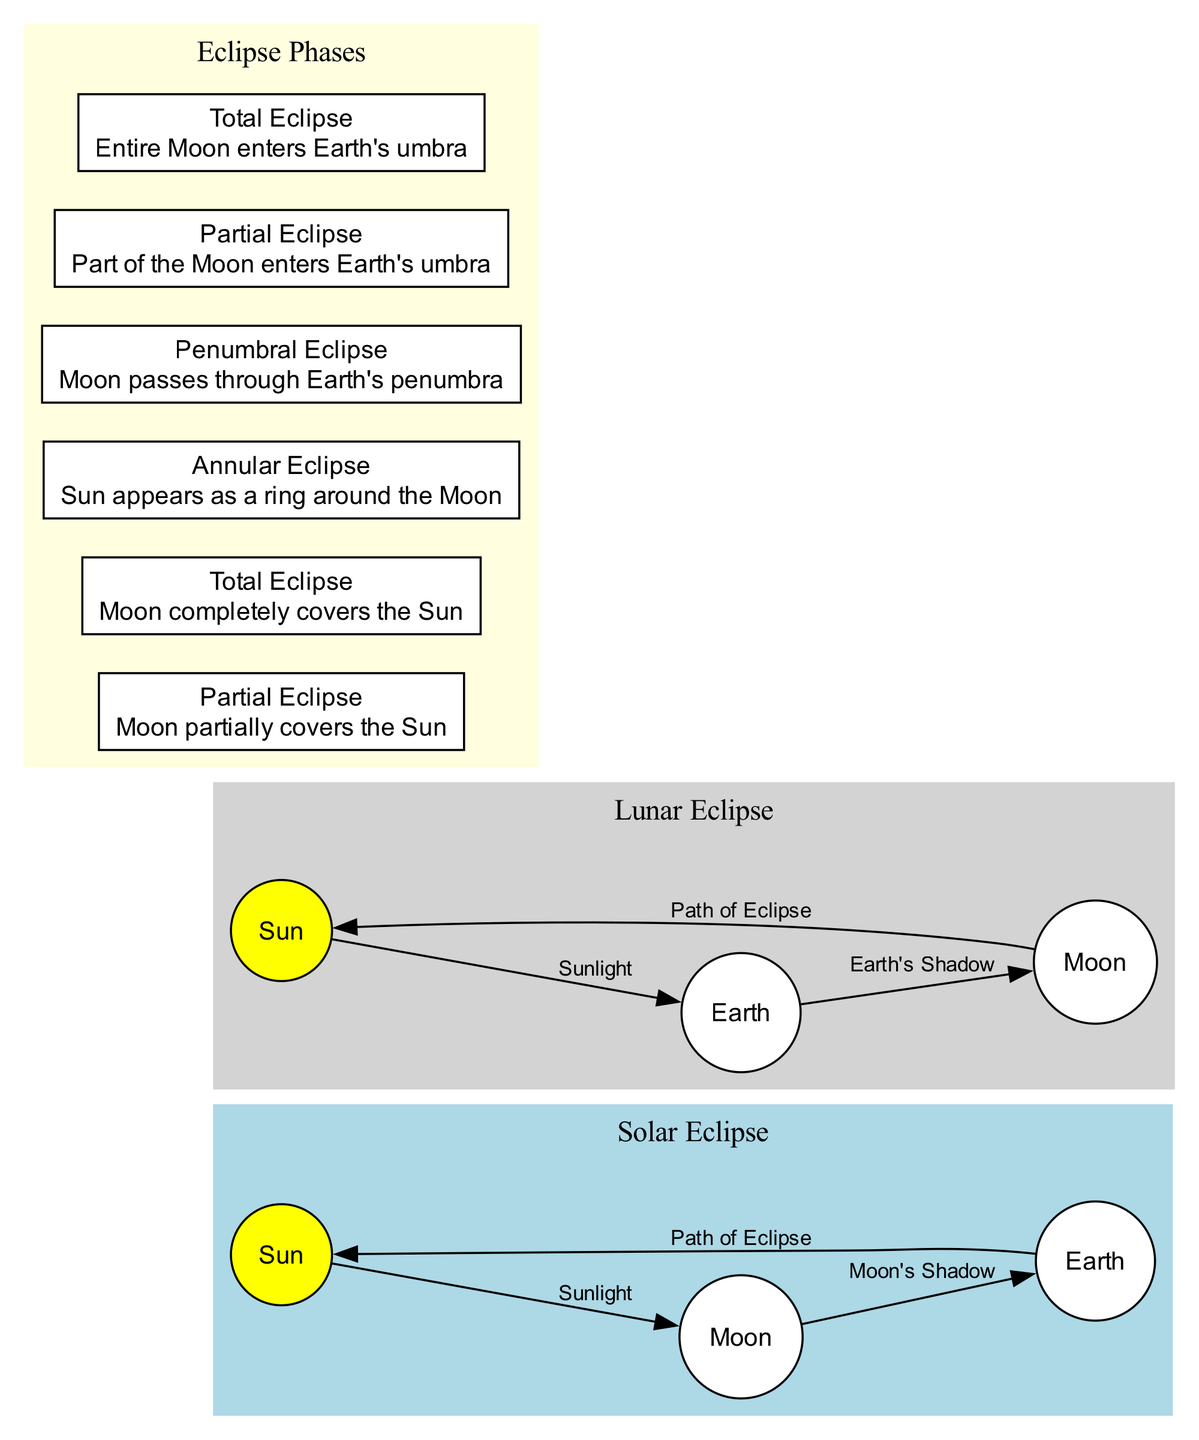What are the three phases of a Solar Eclipse? The diagram lists the phases of a Solar Eclipse as follows: Partial Eclipse, Total Eclipse, and Annular Eclipse. These phases are specifically indicated in the "Eclipse Phases" section under the Solar Eclipse cluster.
Answer: Partial Eclipse, Total Eclipse, Annular Eclipse What is the shadow cast by the Moon during a Solar Eclipse called? In the diagram, the relationship between the Moon and the Earth during a Solar Eclipse indicates that the shadow cast by the Moon on Earth is referred to as "Moon's Shadow." This is clearly labeled in the edges connecting the Moon and Earth.
Answer: Moon's Shadow How many types of Lunar Eclipses are shown in the diagram? The diagram indicates three types of Lunar Eclipses: Penumbral Eclipse, Partial Eclipse, and Total Eclipse. This information is found in the "Eclipse Phases" section under the Lunar Eclipse cluster.
Answer: Three What type of light reaches Earth during a Penumbral Eclipse? During a Penumbral Eclipse, the Moon passes through Earth's penumbra, meaning only some sunlight directly reaches the Moon, resulting in a partial shadow. This interpretation is derived from the description associated with the Penumbral Eclipse phase.
Answer: Some sunlight Which celestial body is at the center of both types of eclipses? In both Solar and Lunar Eclipses, Earth is positioned between the Sun and the Moon, indicating that Earth acts as the central body in this scenario. This is inferred from the diagram's node arrangement and spatial relationships.
Answer: Earth What is the relationship between the Sun and Earth during a Total Eclipse? During a Total Eclipse, the Moon completely covers the Sun, which means that the light from the Sun is blocked by the Moon as it casts its shadow on Earth. This is explained through the direct link described by the edges and the phases indicating the total covering event.
Answer: Moon completely covers Sun What color is used to represent the Sun in the diagram? In the diagram, the Sun is represented in yellow, which is specifically indicated by the fill color assigned to the Sun node within both Solar and Lunar Eclipse clusters.
Answer: Yellow What does the Sun appear as during an Annular Eclipse? During an Annular Eclipse, the diagram states that the Sun appears as a ring around the Moon, highlighting the unique visual phenomenon that occurs when the Moon is slightly farther away from Earth, creating a visible ring of sunlight. This can be found in the description associated with the Annular Eclipse phase.
Answer: A ring around the Moon 